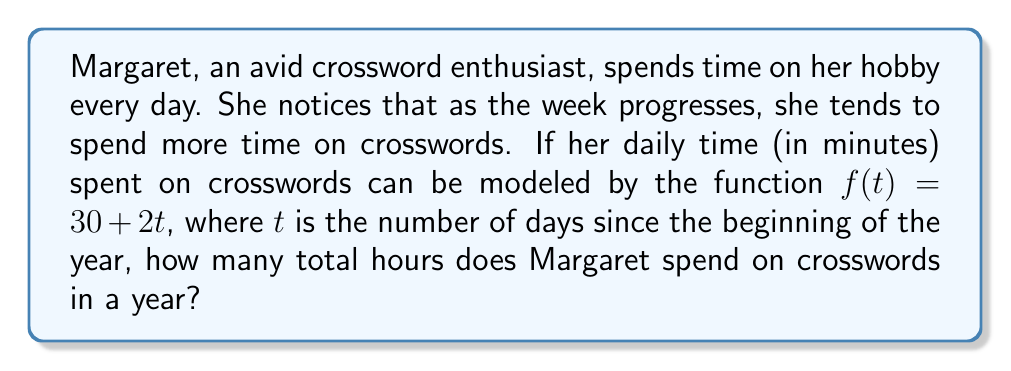Provide a solution to this math problem. Let's approach this step-by-step:

1) The function $f(t) = 30 + 2t$ gives us Margaret's daily time spent on crosswords in minutes.

2) To find the total time for the year, we need to integrate this function from day 0 to day 365:

   $$\text{Total minutes} = \int_0^{365} (30 + 2t) dt$$

3) Let's solve this integral:
   
   $$\int_0^{365} (30 + 2t) dt = \left[30t + t^2\right]_0^{365}$$

4) Evaluate the integral:
   
   $$(30 \cdot 365 + 365^2) - (30 \cdot 0 + 0^2)$$
   
   $$= 10950 + 133225 = 144175 \text{ minutes}$$

5) Convert minutes to hours:
   
   $$144175 \text{ minutes} \div 60 \text{ minutes/hour} = 2402.92 \text{ hours}$$

Therefore, Margaret spends approximately 2403 hours on crosswords in a year.
Answer: 2403 hours 